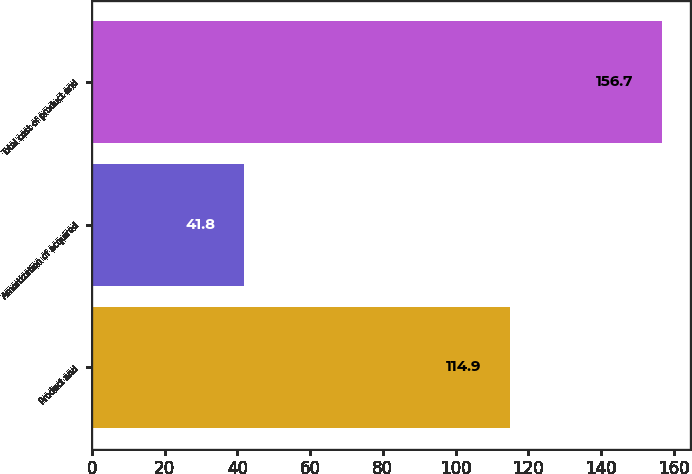Convert chart to OTSL. <chart><loc_0><loc_0><loc_500><loc_500><bar_chart><fcel>Product and<fcel>Amortization of acquired<fcel>Total cost of product and<nl><fcel>114.9<fcel>41.8<fcel>156.7<nl></chart> 